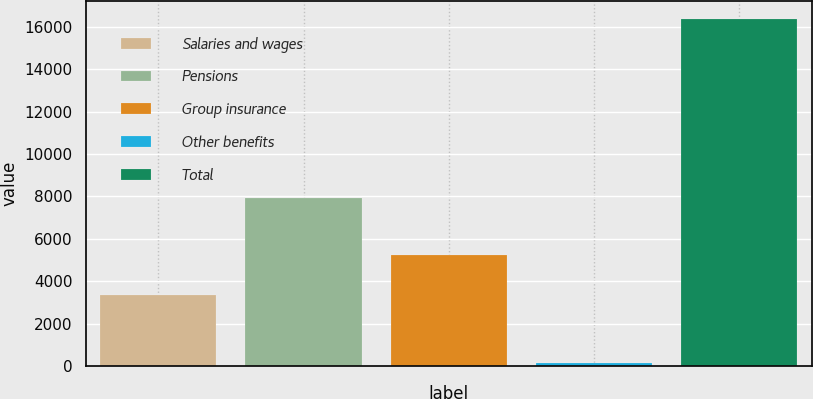<chart> <loc_0><loc_0><loc_500><loc_500><bar_chart><fcel>Salaries and wages<fcel>Pensions<fcel>Group insurance<fcel>Other benefits<fcel>Total<nl><fcel>3348<fcel>7925<fcel>5231<fcel>119<fcel>16385<nl></chart> 